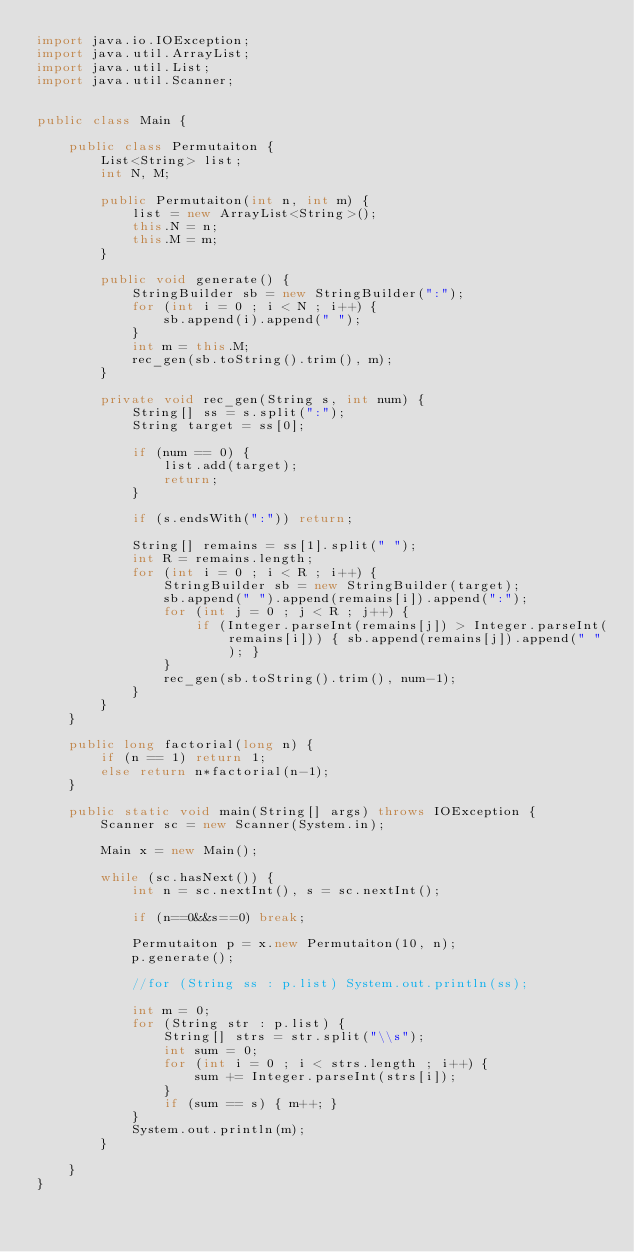Convert code to text. <code><loc_0><loc_0><loc_500><loc_500><_Java_>import java.io.IOException;
import java.util.ArrayList;
import java.util.List;
import java.util.Scanner;


public class Main {

	public class Permutaiton {
		List<String> list;
		int N, M;

		public Permutaiton(int n, int m) {
			list = new ArrayList<String>();
			this.N = n;
			this.M = m;
		}

		public void generate() {
			StringBuilder sb = new StringBuilder(":");
			for (int i = 0 ; i < N ; i++) {
				sb.append(i).append(" ");
			}
			int m = this.M;
			rec_gen(sb.toString().trim(), m);
		}

		private void rec_gen(String s, int num) {
			String[] ss = s.split(":");
			String target = ss[0];

			if (num == 0) {
				list.add(target);
				return;
			}

			if (s.endsWith(":")) return;

			String[] remains = ss[1].split(" ");
			int R = remains.length;
			for (int i = 0 ; i < R ; i++) {
				StringBuilder sb = new StringBuilder(target);
				sb.append(" ").append(remains[i]).append(":");
				for (int j = 0 ; j < R ; j++) {
					if (Integer.parseInt(remains[j]) > Integer.parseInt(remains[i])) { sb.append(remains[j]).append(" "); }
				}
				rec_gen(sb.toString().trim(), num-1);
			}
		}
	}

	public long factorial(long n) {
        if (n == 1) return 1;
        else return n*factorial(n-1);
    }

	public static void main(String[] args) throws IOException {
		Scanner sc = new Scanner(System.in);

		Main x = new Main();

		while (sc.hasNext()) {
			int n = sc.nextInt(), s = sc.nextInt();

			if (n==0&&s==0) break;

			Permutaiton p = x.new Permutaiton(10, n);
			p.generate();

			//for (String ss : p.list) System.out.println(ss);

			int m = 0;
			for (String str : p.list) {
				String[] strs = str.split("\\s");
				int sum = 0;
				for (int i = 0 ; i < strs.length ; i++) {
					sum += Integer.parseInt(strs[i]);
				}
				if (sum == s) { m++; }
			}
			System.out.println(m);
		}

	}
}</code> 